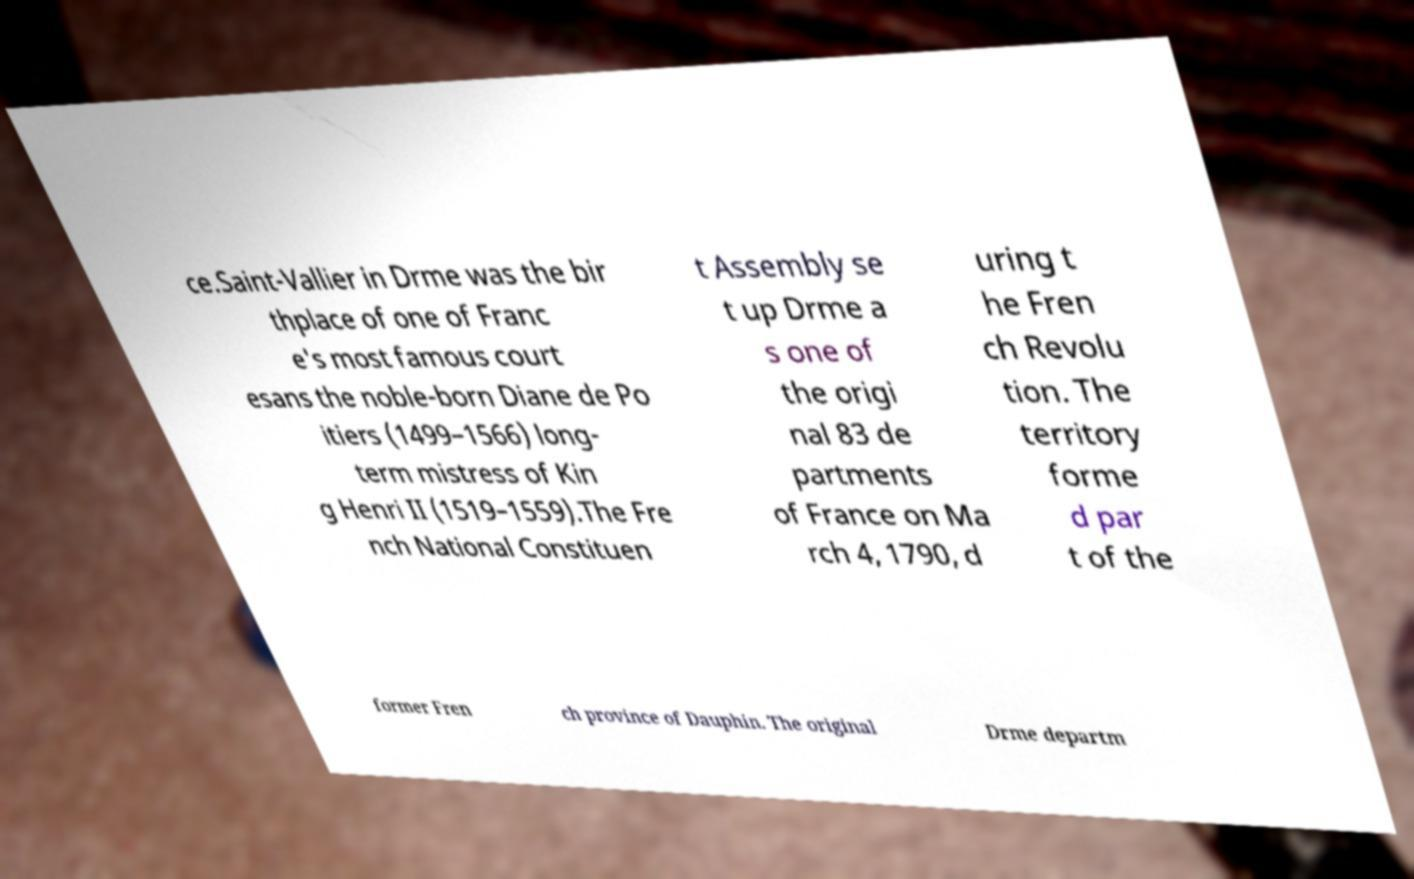Could you extract and type out the text from this image? ce.Saint-Vallier in Drme was the bir thplace of one of Franc e's most famous court esans the noble-born Diane de Po itiers (1499–1566) long- term mistress of Kin g Henri II (1519–1559).The Fre nch National Constituen t Assembly se t up Drme a s one of the origi nal 83 de partments of France on Ma rch 4, 1790, d uring t he Fren ch Revolu tion. The territory forme d par t of the former Fren ch province of Dauphin. The original Drme departm 